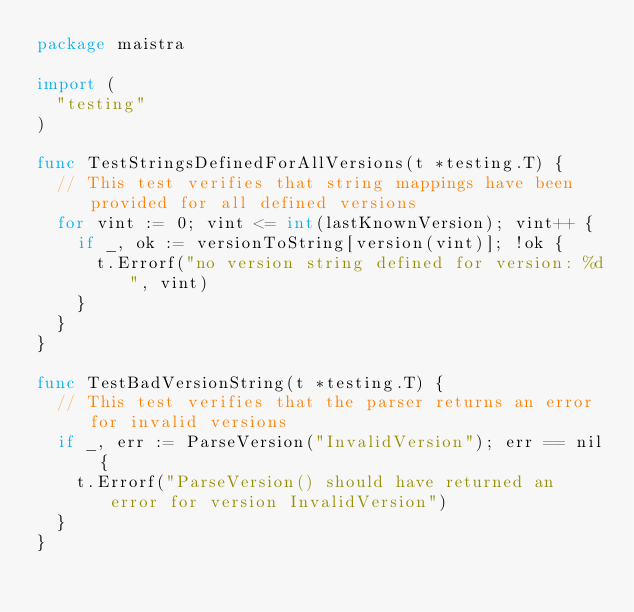Convert code to text. <code><loc_0><loc_0><loc_500><loc_500><_Go_>package maistra

import (
	"testing"
)

func TestStringsDefinedForAllVersions(t *testing.T) {
	// This test verifies that string mappings have been provided for all defined versions
	for vint := 0; vint <= int(lastKnownVersion); vint++ {
		if _, ok := versionToString[version(vint)]; !ok {
			t.Errorf("no version string defined for version: %d", vint)
		}
	}
}

func TestBadVersionString(t *testing.T) {
	// This test verifies that the parser returns an error for invalid versions
	if _, err := ParseVersion("InvalidVersion"); err == nil {
		t.Errorf("ParseVersion() should have returned an error for version InvalidVersion")
	}
}
</code> 